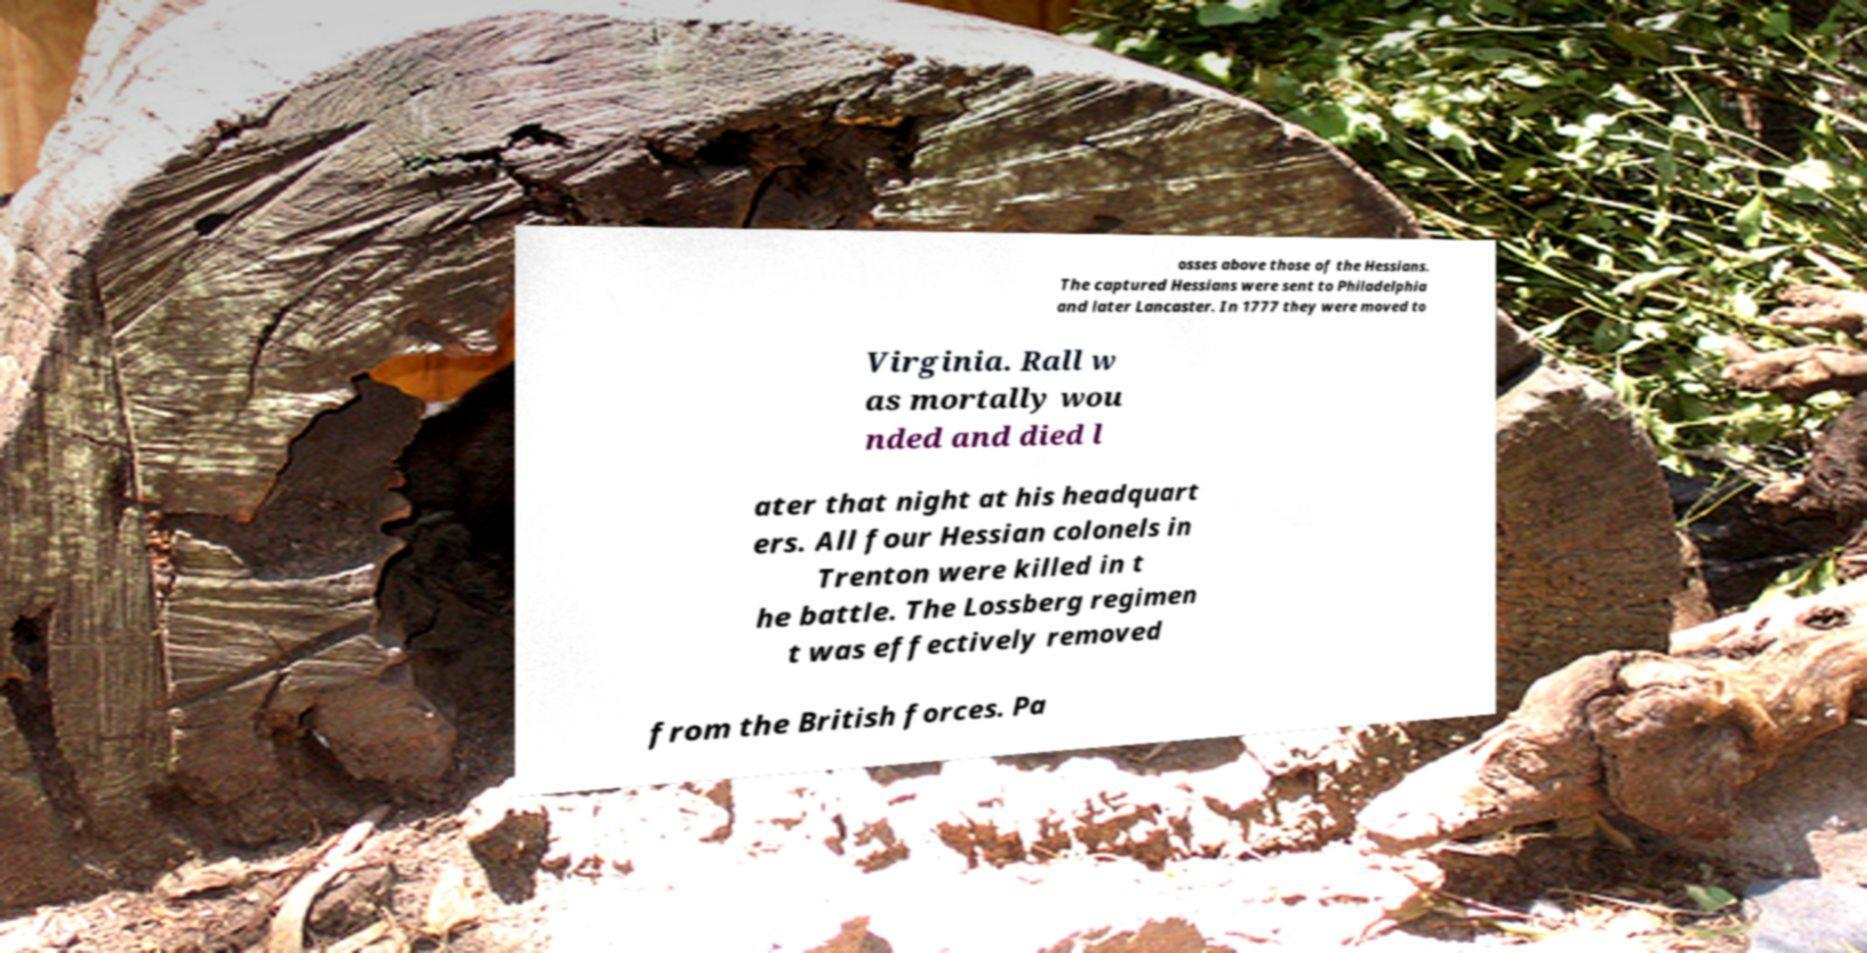There's text embedded in this image that I need extracted. Can you transcribe it verbatim? osses above those of the Hessians. The captured Hessians were sent to Philadelphia and later Lancaster. In 1777 they were moved to Virginia. Rall w as mortally wou nded and died l ater that night at his headquart ers. All four Hessian colonels in Trenton were killed in t he battle. The Lossberg regimen t was effectively removed from the British forces. Pa 